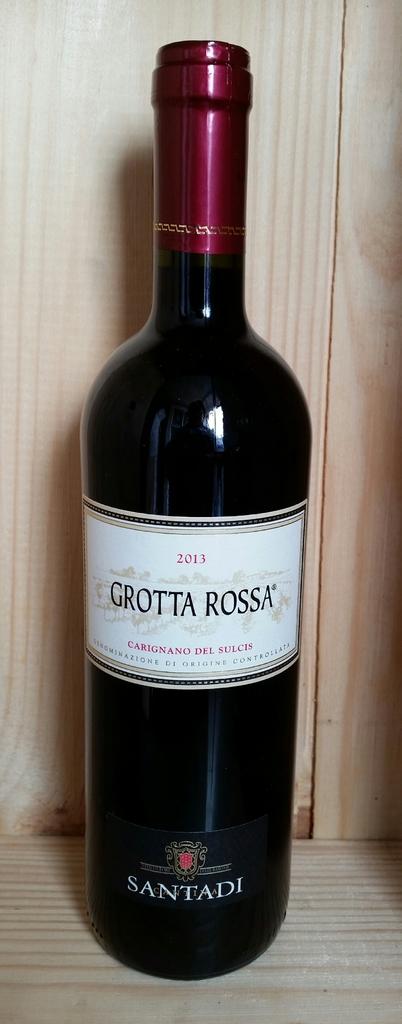In what year was this wine made?
Your answer should be very brief. 2013. What is the brand of the wine?
Provide a short and direct response. Grotta rossa. 